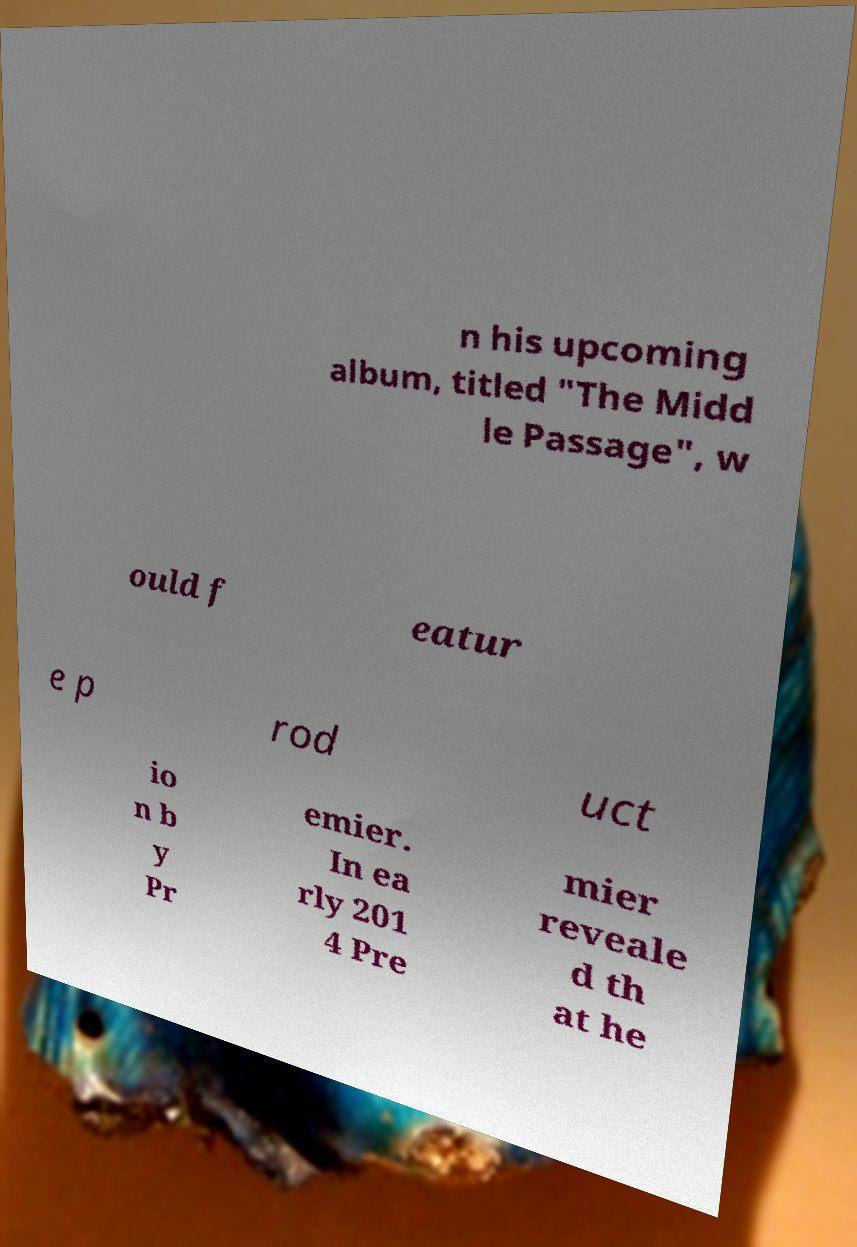Please identify and transcribe the text found in this image. n his upcoming album, titled "The Midd le Passage", w ould f eatur e p rod uct io n b y Pr emier. In ea rly 201 4 Pre mier reveale d th at he 